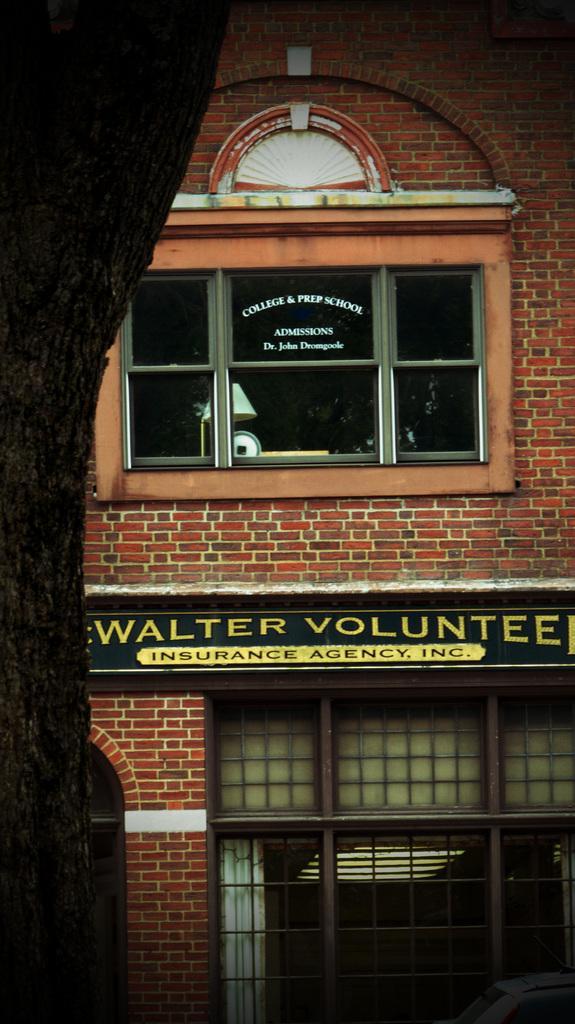How would you summarize this image in a sentence or two? In this picture I can see glass windows. I can see the board. 